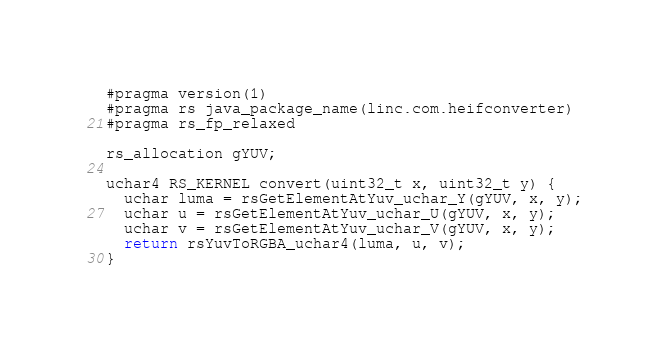<code> <loc_0><loc_0><loc_500><loc_500><_Rust_>#pragma version(1)
#pragma rs java_package_name(linc.com.heifconverter)
#pragma rs_fp_relaxed

rs_allocation gYUV;

uchar4 RS_KERNEL convert(uint32_t x, uint32_t y) {
  uchar luma = rsGetElementAtYuv_uchar_Y(gYUV, x, y);
  uchar u = rsGetElementAtYuv_uchar_U(gYUV, x, y);
  uchar v = rsGetElementAtYuv_uchar_V(gYUV, x, y);
  return rsYuvToRGBA_uchar4(luma, u, v);
}
</code> 